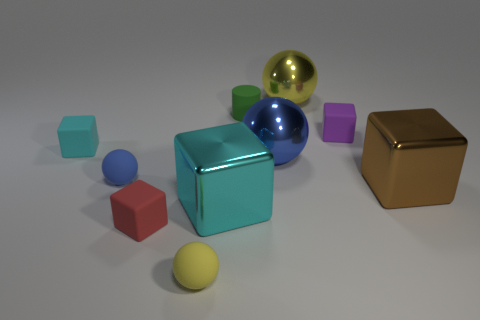Is the number of blue objects left of the green cylinder greater than the number of tiny purple matte cubes that are in front of the tiny blue matte object?
Your answer should be compact. Yes. The blue metal thing is what size?
Your answer should be very brief. Large. What material is the cyan block that is the same size as the red object?
Provide a succinct answer. Rubber. The big metal ball behind the cyan rubber cube is what color?
Give a very brief answer. Yellow. How many purple matte balls are there?
Make the answer very short. 0. Are there any cylinders behind the matte thing that is in front of the block in front of the big cyan thing?
Your response must be concise. Yes. The blue rubber object that is the same size as the purple matte thing is what shape?
Provide a succinct answer. Sphere. How many other things are there of the same color as the tiny cylinder?
Make the answer very short. 0. What is the tiny purple block made of?
Your answer should be very brief. Rubber. What number of other things are there of the same material as the brown cube
Your response must be concise. 3. 